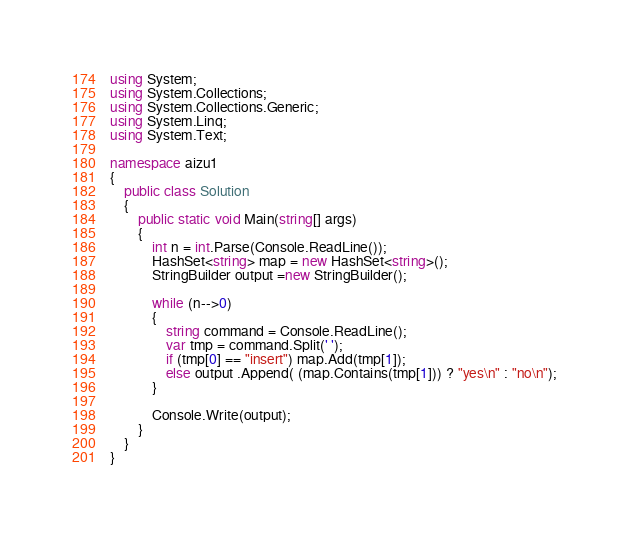<code> <loc_0><loc_0><loc_500><loc_500><_C#_>using System;
using System.Collections;
using System.Collections.Generic;
using System.Linq;
using System.Text;

namespace aizu1
{
    public class Solution
    {
        public static void Main(string[] args)
        {
            int n = int.Parse(Console.ReadLine());
            HashSet<string> map = new HashSet<string>();
            StringBuilder output =new StringBuilder();

            while (n-->0)
            {
                string command = Console.ReadLine();
                var tmp = command.Split(' ');
                if (tmp[0] == "insert") map.Add(tmp[1]);
                else output .Append( (map.Contains(tmp[1])) ? "yes\n" : "no\n");
            }

            Console.Write(output);
        }
    }
}</code> 